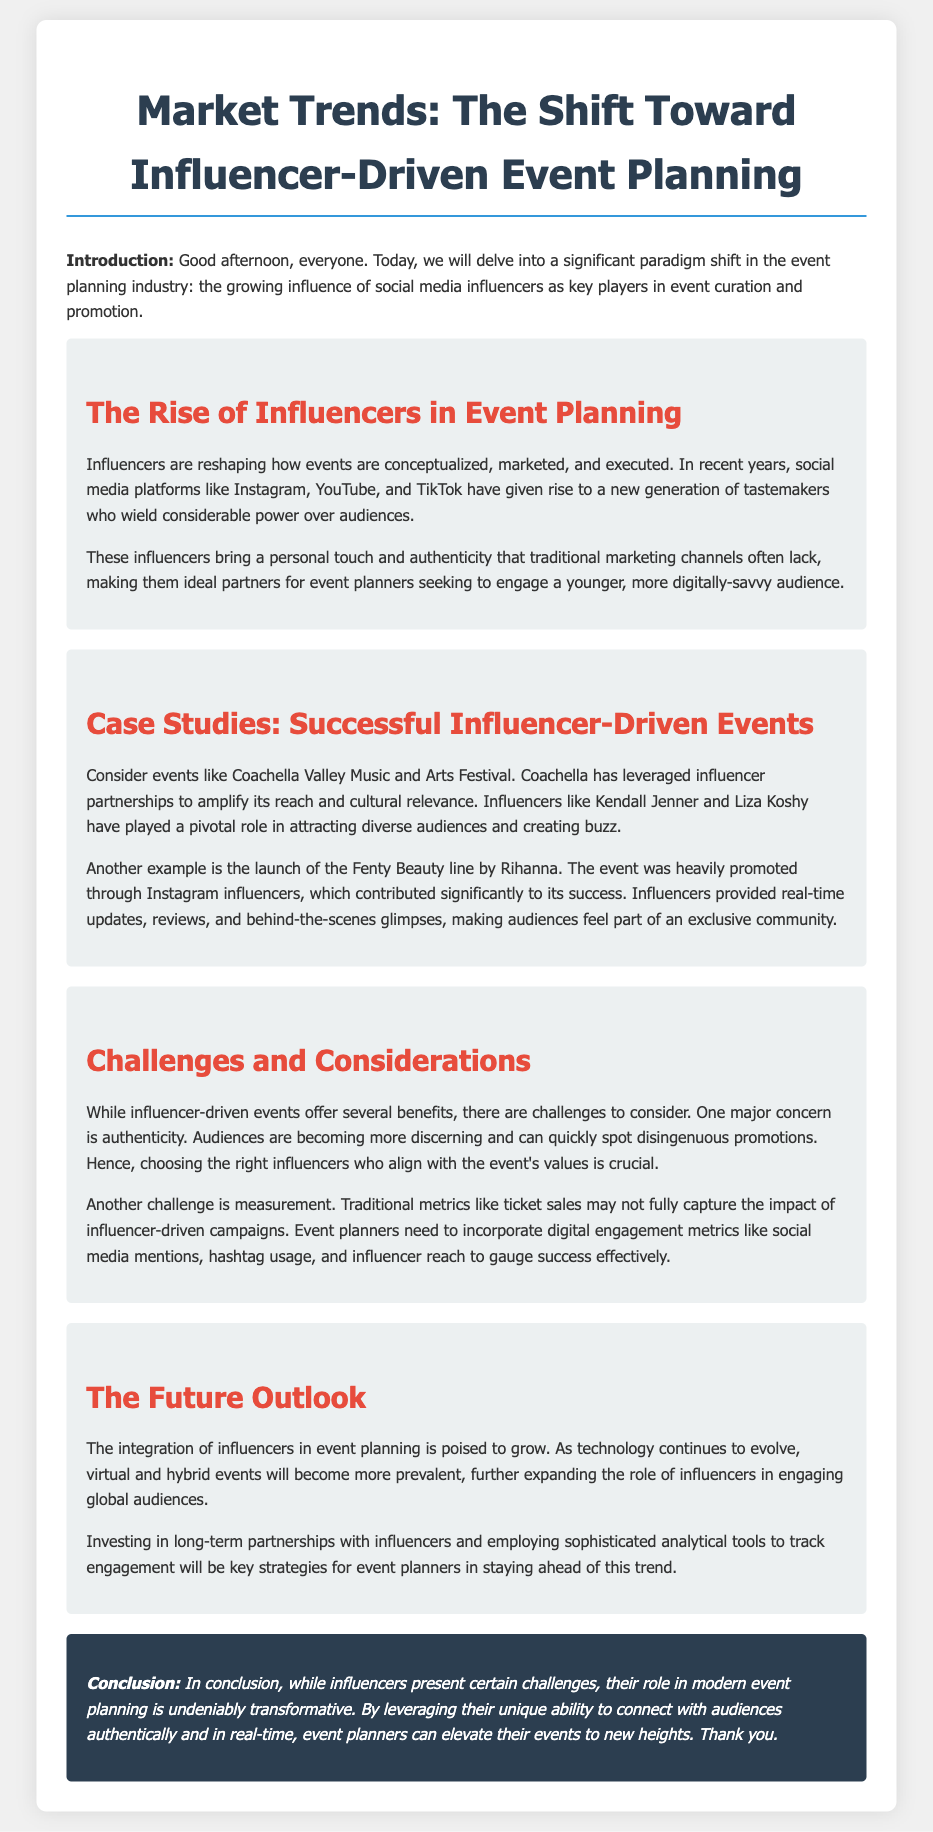What is the main topic of the document? The document discusses the significant shift in the event planning industry due to the rise of influencers.
Answer: Influencer-Driven Event Planning What are two social media platforms mentioned in the document? The document references Instagram and TikTok as key platforms in influencer marketing.
Answer: Instagram, TikTok Who is an example of an influencer mentioned in the case studies? The case studies highlight influencers like Kendall Jenner and Rihanna.
Answer: Kendall Jenner What is a major concern regarding influencer-driven events? Authenticity is a significant concern mentioned in the discussion of challenges.
Answer: Authenticity What type of events will become more prevalent in the future? The document suggests that virtual and hybrid events will increase in prevalence.
Answer: Virtual and hybrid events What strategy is recommended for event planners regarding influencers? The document suggests investing in long-term partnerships with influencers as a key strategy.
Answer: Long-term partnerships 